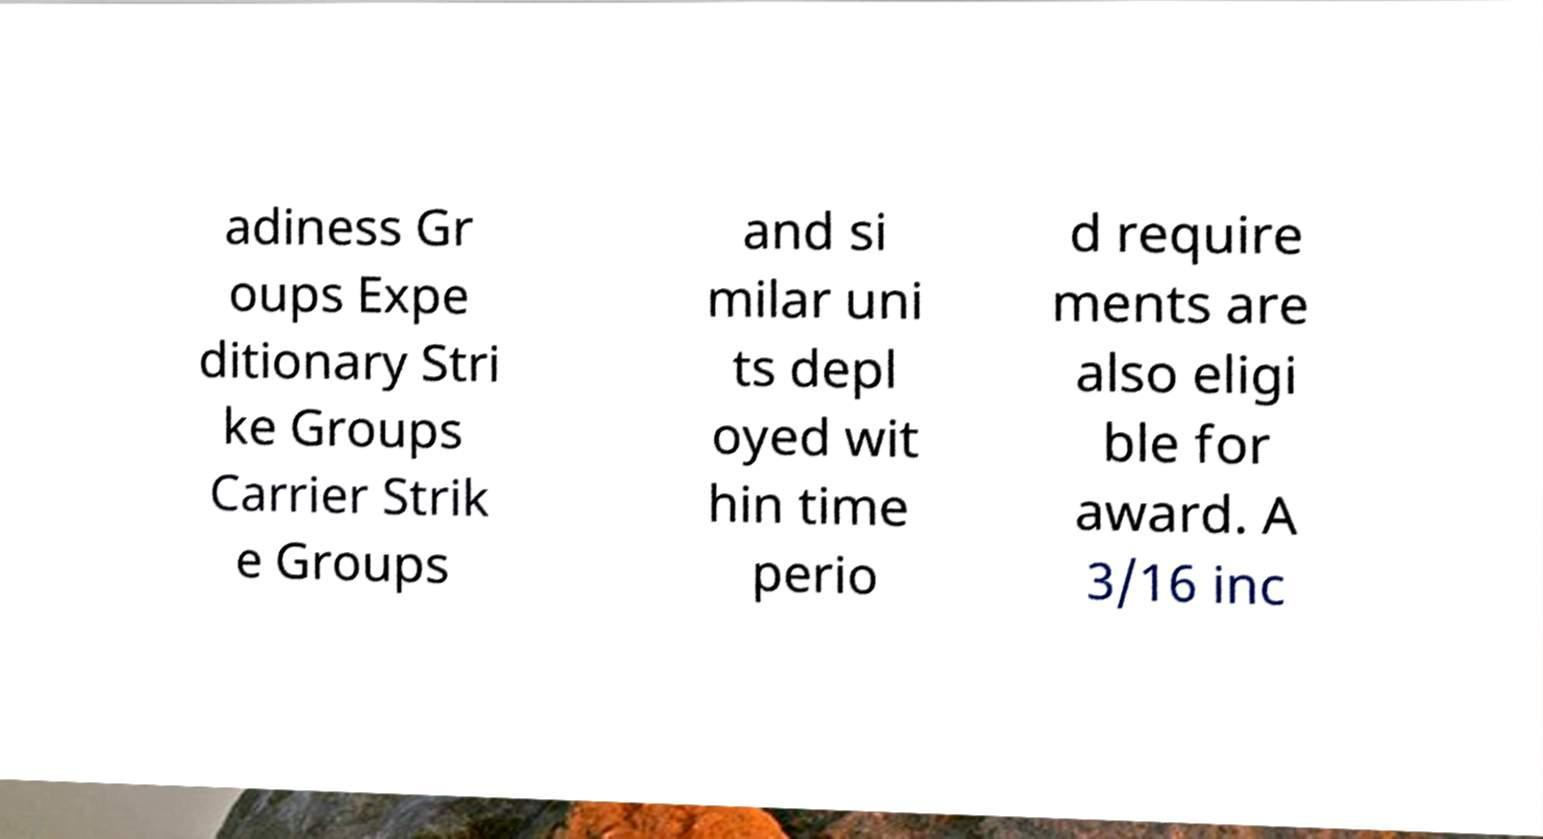Could you assist in decoding the text presented in this image and type it out clearly? adiness Gr oups Expe ditionary Stri ke Groups Carrier Strik e Groups and si milar uni ts depl oyed wit hin time perio d require ments are also eligi ble for award. A 3/16 inc 